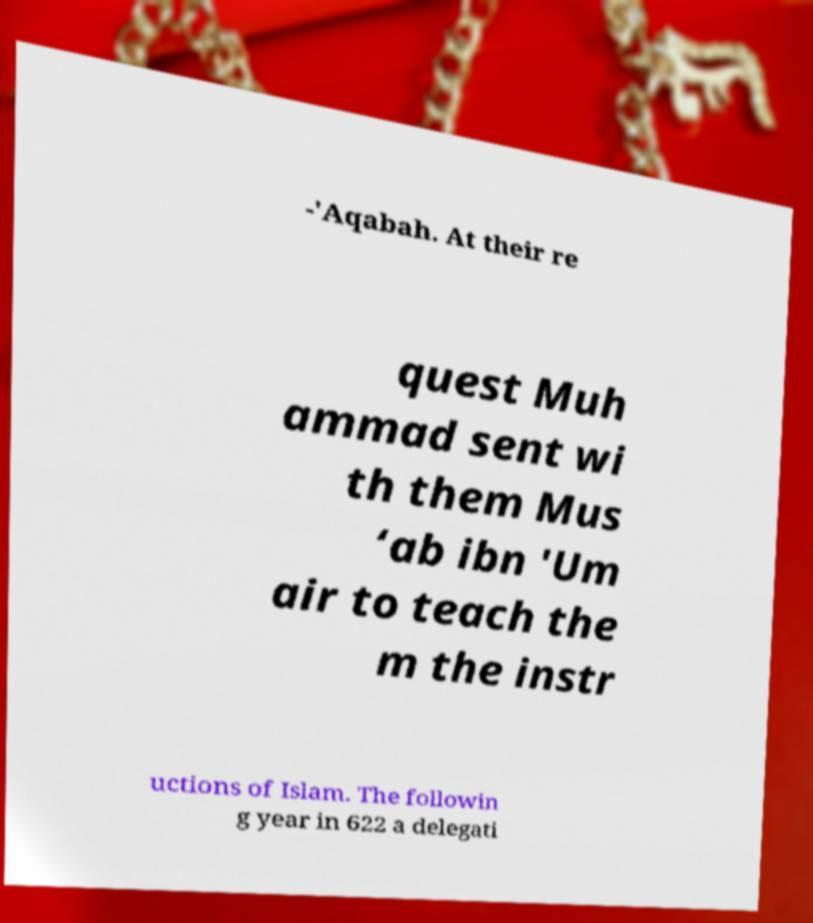Please read and relay the text visible in this image. What does it say? -'Aqabah. At their re quest Muh ammad sent wi th them Mus ‘ab ibn 'Um air to teach the m the instr uctions of Islam. The followin g year in 622 a delegati 